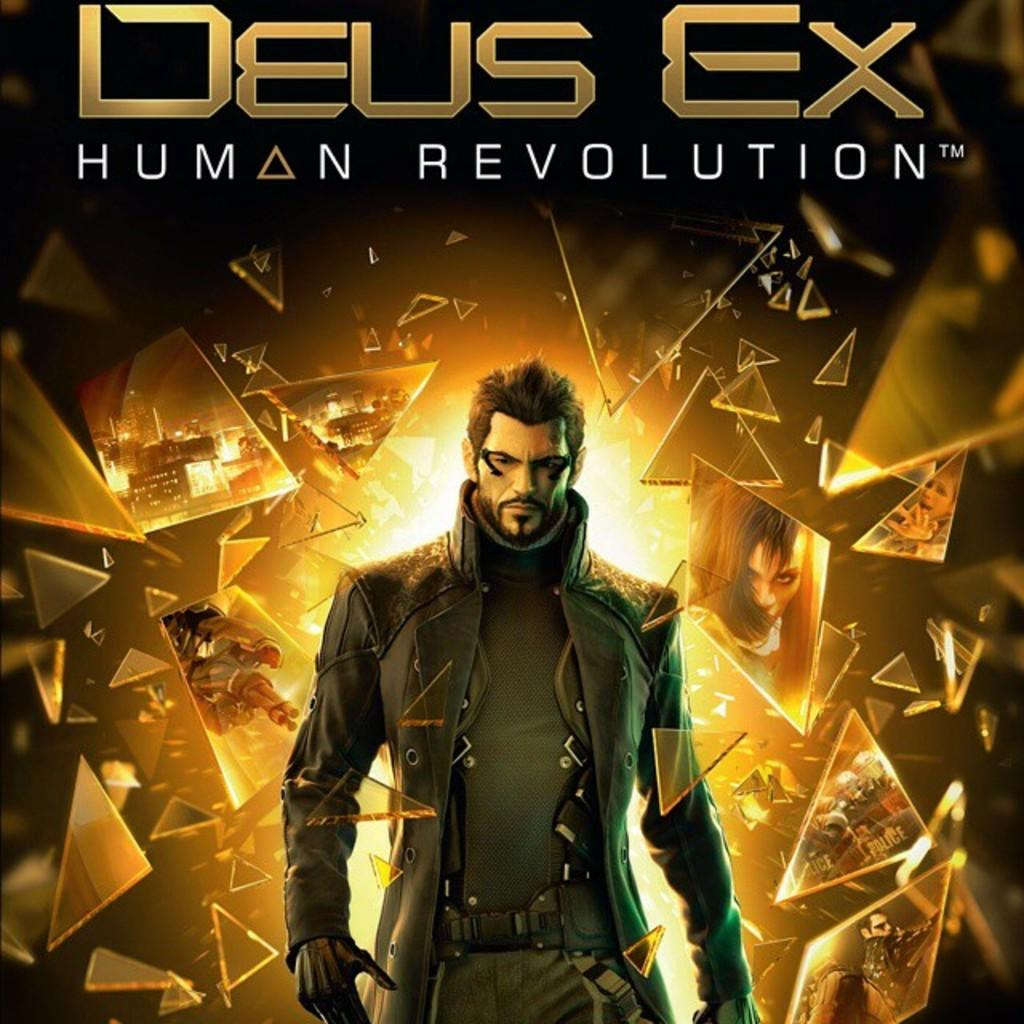<image>
Give a short and clear explanation of the subsequent image. some kind of game that says Deus Ex at the top 